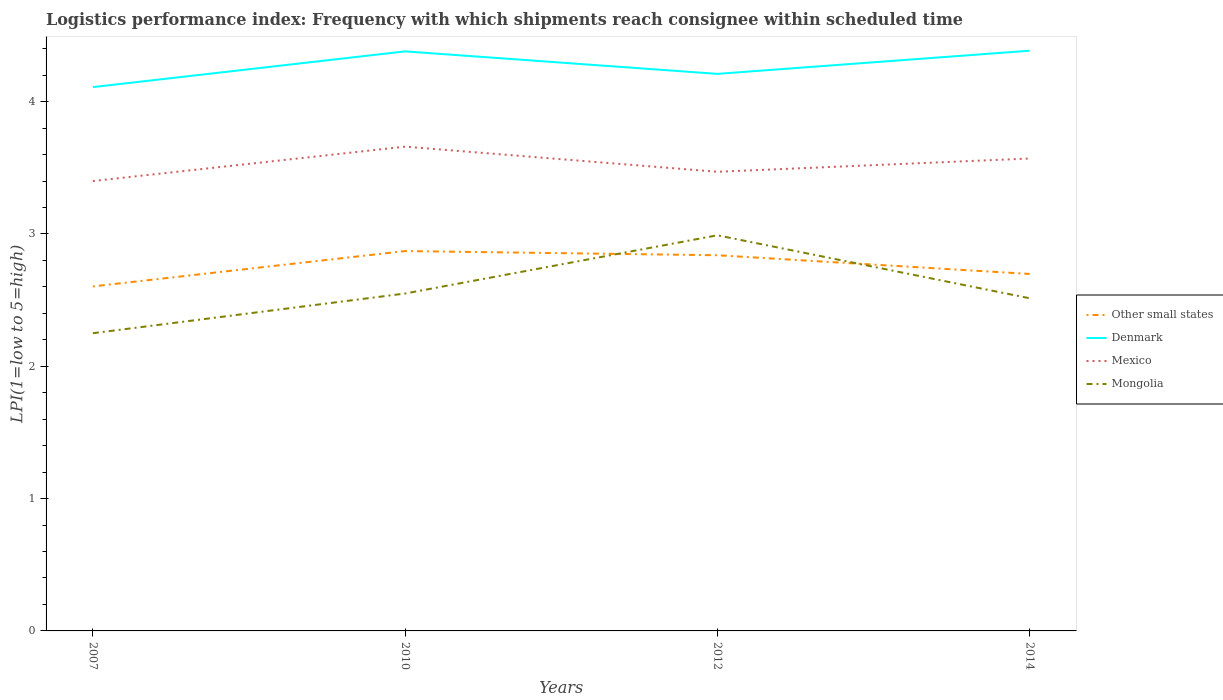How many different coloured lines are there?
Keep it short and to the point. 4. Across all years, what is the maximum logistics performance index in Other small states?
Keep it short and to the point. 2.6. In which year was the logistics performance index in Denmark maximum?
Provide a succinct answer. 2007. What is the total logistics performance index in Denmark in the graph?
Your answer should be very brief. 0.17. What is the difference between the highest and the second highest logistics performance index in Mongolia?
Your answer should be compact. 0.74. Is the logistics performance index in Mongolia strictly greater than the logistics performance index in Other small states over the years?
Your answer should be compact. No. How many lines are there?
Your response must be concise. 4. Are the values on the major ticks of Y-axis written in scientific E-notation?
Your response must be concise. No. Does the graph contain any zero values?
Give a very brief answer. No. Does the graph contain grids?
Offer a terse response. No. Where does the legend appear in the graph?
Provide a succinct answer. Center right. How are the legend labels stacked?
Ensure brevity in your answer.  Vertical. What is the title of the graph?
Your response must be concise. Logistics performance index: Frequency with which shipments reach consignee within scheduled time. What is the label or title of the X-axis?
Give a very brief answer. Years. What is the label or title of the Y-axis?
Provide a succinct answer. LPI(1=low to 5=high). What is the LPI(1=low to 5=high) of Other small states in 2007?
Ensure brevity in your answer.  2.6. What is the LPI(1=low to 5=high) of Denmark in 2007?
Your response must be concise. 4.11. What is the LPI(1=low to 5=high) in Mongolia in 2007?
Your answer should be very brief. 2.25. What is the LPI(1=low to 5=high) in Other small states in 2010?
Your answer should be compact. 2.87. What is the LPI(1=low to 5=high) in Denmark in 2010?
Offer a terse response. 4.38. What is the LPI(1=low to 5=high) in Mexico in 2010?
Your response must be concise. 3.66. What is the LPI(1=low to 5=high) of Mongolia in 2010?
Ensure brevity in your answer.  2.55. What is the LPI(1=low to 5=high) of Other small states in 2012?
Your response must be concise. 2.84. What is the LPI(1=low to 5=high) of Denmark in 2012?
Provide a succinct answer. 4.21. What is the LPI(1=low to 5=high) in Mexico in 2012?
Offer a very short reply. 3.47. What is the LPI(1=low to 5=high) in Mongolia in 2012?
Offer a very short reply. 2.99. What is the LPI(1=low to 5=high) of Other small states in 2014?
Keep it short and to the point. 2.7. What is the LPI(1=low to 5=high) of Denmark in 2014?
Your answer should be compact. 4.39. What is the LPI(1=low to 5=high) in Mexico in 2014?
Give a very brief answer. 3.57. What is the LPI(1=low to 5=high) in Mongolia in 2014?
Offer a very short reply. 2.51. Across all years, what is the maximum LPI(1=low to 5=high) of Other small states?
Give a very brief answer. 2.87. Across all years, what is the maximum LPI(1=low to 5=high) in Denmark?
Offer a terse response. 4.39. Across all years, what is the maximum LPI(1=low to 5=high) in Mexico?
Ensure brevity in your answer.  3.66. Across all years, what is the maximum LPI(1=low to 5=high) of Mongolia?
Provide a short and direct response. 2.99. Across all years, what is the minimum LPI(1=low to 5=high) in Other small states?
Your response must be concise. 2.6. Across all years, what is the minimum LPI(1=low to 5=high) in Denmark?
Give a very brief answer. 4.11. Across all years, what is the minimum LPI(1=low to 5=high) of Mexico?
Provide a succinct answer. 3.4. Across all years, what is the minimum LPI(1=low to 5=high) in Mongolia?
Provide a short and direct response. 2.25. What is the total LPI(1=low to 5=high) of Other small states in the graph?
Keep it short and to the point. 11.01. What is the total LPI(1=low to 5=high) of Denmark in the graph?
Your answer should be very brief. 17.09. What is the total LPI(1=low to 5=high) of Mexico in the graph?
Give a very brief answer. 14.1. What is the total LPI(1=low to 5=high) in Mongolia in the graph?
Your response must be concise. 10.3. What is the difference between the LPI(1=low to 5=high) in Other small states in 2007 and that in 2010?
Your answer should be very brief. -0.27. What is the difference between the LPI(1=low to 5=high) of Denmark in 2007 and that in 2010?
Your answer should be very brief. -0.27. What is the difference between the LPI(1=low to 5=high) in Mexico in 2007 and that in 2010?
Your answer should be very brief. -0.26. What is the difference between the LPI(1=low to 5=high) of Mongolia in 2007 and that in 2010?
Provide a succinct answer. -0.3. What is the difference between the LPI(1=low to 5=high) in Other small states in 2007 and that in 2012?
Your answer should be compact. -0.24. What is the difference between the LPI(1=low to 5=high) in Mexico in 2007 and that in 2012?
Your answer should be compact. -0.07. What is the difference between the LPI(1=low to 5=high) in Mongolia in 2007 and that in 2012?
Give a very brief answer. -0.74. What is the difference between the LPI(1=low to 5=high) of Other small states in 2007 and that in 2014?
Offer a terse response. -0.09. What is the difference between the LPI(1=low to 5=high) of Denmark in 2007 and that in 2014?
Your answer should be compact. -0.28. What is the difference between the LPI(1=low to 5=high) of Mexico in 2007 and that in 2014?
Your answer should be very brief. -0.17. What is the difference between the LPI(1=low to 5=high) in Mongolia in 2007 and that in 2014?
Make the answer very short. -0.26. What is the difference between the LPI(1=low to 5=high) of Other small states in 2010 and that in 2012?
Your answer should be very brief. 0.03. What is the difference between the LPI(1=low to 5=high) of Denmark in 2010 and that in 2012?
Your answer should be very brief. 0.17. What is the difference between the LPI(1=low to 5=high) in Mexico in 2010 and that in 2012?
Provide a succinct answer. 0.19. What is the difference between the LPI(1=low to 5=high) of Mongolia in 2010 and that in 2012?
Offer a terse response. -0.44. What is the difference between the LPI(1=low to 5=high) in Other small states in 2010 and that in 2014?
Ensure brevity in your answer.  0.17. What is the difference between the LPI(1=low to 5=high) of Denmark in 2010 and that in 2014?
Make the answer very short. -0.01. What is the difference between the LPI(1=low to 5=high) of Mexico in 2010 and that in 2014?
Ensure brevity in your answer.  0.09. What is the difference between the LPI(1=low to 5=high) of Mongolia in 2010 and that in 2014?
Your answer should be compact. 0.04. What is the difference between the LPI(1=low to 5=high) in Other small states in 2012 and that in 2014?
Offer a very short reply. 0.14. What is the difference between the LPI(1=low to 5=high) of Denmark in 2012 and that in 2014?
Make the answer very short. -0.18. What is the difference between the LPI(1=low to 5=high) in Mexico in 2012 and that in 2014?
Make the answer very short. -0.1. What is the difference between the LPI(1=low to 5=high) in Mongolia in 2012 and that in 2014?
Your answer should be very brief. 0.48. What is the difference between the LPI(1=low to 5=high) in Other small states in 2007 and the LPI(1=low to 5=high) in Denmark in 2010?
Keep it short and to the point. -1.78. What is the difference between the LPI(1=low to 5=high) of Other small states in 2007 and the LPI(1=low to 5=high) of Mexico in 2010?
Offer a very short reply. -1.06. What is the difference between the LPI(1=low to 5=high) of Other small states in 2007 and the LPI(1=low to 5=high) of Mongolia in 2010?
Give a very brief answer. 0.05. What is the difference between the LPI(1=low to 5=high) in Denmark in 2007 and the LPI(1=low to 5=high) in Mexico in 2010?
Provide a short and direct response. 0.45. What is the difference between the LPI(1=low to 5=high) in Denmark in 2007 and the LPI(1=low to 5=high) in Mongolia in 2010?
Give a very brief answer. 1.56. What is the difference between the LPI(1=low to 5=high) in Mexico in 2007 and the LPI(1=low to 5=high) in Mongolia in 2010?
Provide a short and direct response. 0.85. What is the difference between the LPI(1=low to 5=high) in Other small states in 2007 and the LPI(1=low to 5=high) in Denmark in 2012?
Provide a succinct answer. -1.61. What is the difference between the LPI(1=low to 5=high) of Other small states in 2007 and the LPI(1=low to 5=high) of Mexico in 2012?
Your response must be concise. -0.87. What is the difference between the LPI(1=low to 5=high) of Other small states in 2007 and the LPI(1=low to 5=high) of Mongolia in 2012?
Provide a succinct answer. -0.39. What is the difference between the LPI(1=low to 5=high) in Denmark in 2007 and the LPI(1=low to 5=high) in Mexico in 2012?
Your response must be concise. 0.64. What is the difference between the LPI(1=low to 5=high) of Denmark in 2007 and the LPI(1=low to 5=high) of Mongolia in 2012?
Make the answer very short. 1.12. What is the difference between the LPI(1=low to 5=high) of Mexico in 2007 and the LPI(1=low to 5=high) of Mongolia in 2012?
Keep it short and to the point. 0.41. What is the difference between the LPI(1=low to 5=high) of Other small states in 2007 and the LPI(1=low to 5=high) of Denmark in 2014?
Keep it short and to the point. -1.78. What is the difference between the LPI(1=low to 5=high) in Other small states in 2007 and the LPI(1=low to 5=high) in Mexico in 2014?
Keep it short and to the point. -0.97. What is the difference between the LPI(1=low to 5=high) in Other small states in 2007 and the LPI(1=low to 5=high) in Mongolia in 2014?
Provide a succinct answer. 0.09. What is the difference between the LPI(1=low to 5=high) in Denmark in 2007 and the LPI(1=low to 5=high) in Mexico in 2014?
Your response must be concise. 0.54. What is the difference between the LPI(1=low to 5=high) in Denmark in 2007 and the LPI(1=low to 5=high) in Mongolia in 2014?
Offer a very short reply. 1.6. What is the difference between the LPI(1=low to 5=high) in Mexico in 2007 and the LPI(1=low to 5=high) in Mongolia in 2014?
Ensure brevity in your answer.  0.89. What is the difference between the LPI(1=low to 5=high) in Other small states in 2010 and the LPI(1=low to 5=high) in Denmark in 2012?
Ensure brevity in your answer.  -1.34. What is the difference between the LPI(1=low to 5=high) in Other small states in 2010 and the LPI(1=low to 5=high) in Mexico in 2012?
Your response must be concise. -0.6. What is the difference between the LPI(1=low to 5=high) in Other small states in 2010 and the LPI(1=low to 5=high) in Mongolia in 2012?
Give a very brief answer. -0.12. What is the difference between the LPI(1=low to 5=high) of Denmark in 2010 and the LPI(1=low to 5=high) of Mexico in 2012?
Offer a very short reply. 0.91. What is the difference between the LPI(1=low to 5=high) in Denmark in 2010 and the LPI(1=low to 5=high) in Mongolia in 2012?
Offer a very short reply. 1.39. What is the difference between the LPI(1=low to 5=high) of Mexico in 2010 and the LPI(1=low to 5=high) of Mongolia in 2012?
Provide a succinct answer. 0.67. What is the difference between the LPI(1=low to 5=high) in Other small states in 2010 and the LPI(1=low to 5=high) in Denmark in 2014?
Your answer should be compact. -1.51. What is the difference between the LPI(1=low to 5=high) of Other small states in 2010 and the LPI(1=low to 5=high) of Mexico in 2014?
Your answer should be compact. -0.7. What is the difference between the LPI(1=low to 5=high) of Other small states in 2010 and the LPI(1=low to 5=high) of Mongolia in 2014?
Give a very brief answer. 0.36. What is the difference between the LPI(1=low to 5=high) of Denmark in 2010 and the LPI(1=low to 5=high) of Mexico in 2014?
Give a very brief answer. 0.81. What is the difference between the LPI(1=low to 5=high) in Denmark in 2010 and the LPI(1=low to 5=high) in Mongolia in 2014?
Provide a succinct answer. 1.87. What is the difference between the LPI(1=low to 5=high) in Mexico in 2010 and the LPI(1=low to 5=high) in Mongolia in 2014?
Give a very brief answer. 1.15. What is the difference between the LPI(1=low to 5=high) of Other small states in 2012 and the LPI(1=low to 5=high) of Denmark in 2014?
Your answer should be very brief. -1.55. What is the difference between the LPI(1=low to 5=high) in Other small states in 2012 and the LPI(1=low to 5=high) in Mexico in 2014?
Your response must be concise. -0.73. What is the difference between the LPI(1=low to 5=high) in Other small states in 2012 and the LPI(1=low to 5=high) in Mongolia in 2014?
Ensure brevity in your answer.  0.33. What is the difference between the LPI(1=low to 5=high) in Denmark in 2012 and the LPI(1=low to 5=high) in Mexico in 2014?
Provide a short and direct response. 0.64. What is the difference between the LPI(1=low to 5=high) in Denmark in 2012 and the LPI(1=low to 5=high) in Mongolia in 2014?
Offer a very short reply. 1.7. What is the difference between the LPI(1=low to 5=high) in Mexico in 2012 and the LPI(1=low to 5=high) in Mongolia in 2014?
Make the answer very short. 0.96. What is the average LPI(1=low to 5=high) of Other small states per year?
Provide a succinct answer. 2.75. What is the average LPI(1=low to 5=high) of Denmark per year?
Your answer should be compact. 4.27. What is the average LPI(1=low to 5=high) of Mexico per year?
Provide a succinct answer. 3.53. What is the average LPI(1=low to 5=high) of Mongolia per year?
Your answer should be very brief. 2.58. In the year 2007, what is the difference between the LPI(1=low to 5=high) in Other small states and LPI(1=low to 5=high) in Denmark?
Provide a succinct answer. -1.51. In the year 2007, what is the difference between the LPI(1=low to 5=high) in Other small states and LPI(1=low to 5=high) in Mexico?
Make the answer very short. -0.8. In the year 2007, what is the difference between the LPI(1=low to 5=high) in Other small states and LPI(1=low to 5=high) in Mongolia?
Your answer should be compact. 0.35. In the year 2007, what is the difference between the LPI(1=low to 5=high) in Denmark and LPI(1=low to 5=high) in Mexico?
Ensure brevity in your answer.  0.71. In the year 2007, what is the difference between the LPI(1=low to 5=high) of Denmark and LPI(1=low to 5=high) of Mongolia?
Your answer should be very brief. 1.86. In the year 2007, what is the difference between the LPI(1=low to 5=high) in Mexico and LPI(1=low to 5=high) in Mongolia?
Give a very brief answer. 1.15. In the year 2010, what is the difference between the LPI(1=low to 5=high) in Other small states and LPI(1=low to 5=high) in Denmark?
Offer a very short reply. -1.51. In the year 2010, what is the difference between the LPI(1=low to 5=high) in Other small states and LPI(1=low to 5=high) in Mexico?
Offer a very short reply. -0.79. In the year 2010, what is the difference between the LPI(1=low to 5=high) of Other small states and LPI(1=low to 5=high) of Mongolia?
Provide a succinct answer. 0.32. In the year 2010, what is the difference between the LPI(1=low to 5=high) in Denmark and LPI(1=low to 5=high) in Mexico?
Make the answer very short. 0.72. In the year 2010, what is the difference between the LPI(1=low to 5=high) of Denmark and LPI(1=low to 5=high) of Mongolia?
Your response must be concise. 1.83. In the year 2010, what is the difference between the LPI(1=low to 5=high) of Mexico and LPI(1=low to 5=high) of Mongolia?
Your response must be concise. 1.11. In the year 2012, what is the difference between the LPI(1=low to 5=high) of Other small states and LPI(1=low to 5=high) of Denmark?
Your answer should be compact. -1.37. In the year 2012, what is the difference between the LPI(1=low to 5=high) of Other small states and LPI(1=low to 5=high) of Mexico?
Offer a terse response. -0.63. In the year 2012, what is the difference between the LPI(1=low to 5=high) in Other small states and LPI(1=low to 5=high) in Mongolia?
Provide a short and direct response. -0.15. In the year 2012, what is the difference between the LPI(1=low to 5=high) in Denmark and LPI(1=low to 5=high) in Mexico?
Offer a terse response. 0.74. In the year 2012, what is the difference between the LPI(1=low to 5=high) of Denmark and LPI(1=low to 5=high) of Mongolia?
Provide a short and direct response. 1.22. In the year 2012, what is the difference between the LPI(1=low to 5=high) of Mexico and LPI(1=low to 5=high) of Mongolia?
Give a very brief answer. 0.48. In the year 2014, what is the difference between the LPI(1=low to 5=high) in Other small states and LPI(1=low to 5=high) in Denmark?
Provide a succinct answer. -1.69. In the year 2014, what is the difference between the LPI(1=low to 5=high) of Other small states and LPI(1=low to 5=high) of Mexico?
Give a very brief answer. -0.87. In the year 2014, what is the difference between the LPI(1=low to 5=high) in Other small states and LPI(1=low to 5=high) in Mongolia?
Offer a terse response. 0.18. In the year 2014, what is the difference between the LPI(1=low to 5=high) in Denmark and LPI(1=low to 5=high) in Mexico?
Your answer should be very brief. 0.81. In the year 2014, what is the difference between the LPI(1=low to 5=high) in Denmark and LPI(1=low to 5=high) in Mongolia?
Ensure brevity in your answer.  1.87. In the year 2014, what is the difference between the LPI(1=low to 5=high) of Mexico and LPI(1=low to 5=high) of Mongolia?
Make the answer very short. 1.06. What is the ratio of the LPI(1=low to 5=high) in Other small states in 2007 to that in 2010?
Offer a very short reply. 0.91. What is the ratio of the LPI(1=low to 5=high) of Denmark in 2007 to that in 2010?
Your answer should be very brief. 0.94. What is the ratio of the LPI(1=low to 5=high) of Mexico in 2007 to that in 2010?
Offer a terse response. 0.93. What is the ratio of the LPI(1=low to 5=high) in Mongolia in 2007 to that in 2010?
Ensure brevity in your answer.  0.88. What is the ratio of the LPI(1=low to 5=high) in Other small states in 2007 to that in 2012?
Keep it short and to the point. 0.92. What is the ratio of the LPI(1=low to 5=high) of Denmark in 2007 to that in 2012?
Offer a terse response. 0.98. What is the ratio of the LPI(1=low to 5=high) of Mexico in 2007 to that in 2012?
Offer a terse response. 0.98. What is the ratio of the LPI(1=low to 5=high) of Mongolia in 2007 to that in 2012?
Ensure brevity in your answer.  0.75. What is the ratio of the LPI(1=low to 5=high) in Other small states in 2007 to that in 2014?
Your response must be concise. 0.97. What is the ratio of the LPI(1=low to 5=high) in Denmark in 2007 to that in 2014?
Offer a terse response. 0.94. What is the ratio of the LPI(1=low to 5=high) of Mexico in 2007 to that in 2014?
Give a very brief answer. 0.95. What is the ratio of the LPI(1=low to 5=high) in Mongolia in 2007 to that in 2014?
Your response must be concise. 0.89. What is the ratio of the LPI(1=low to 5=high) of Other small states in 2010 to that in 2012?
Provide a short and direct response. 1.01. What is the ratio of the LPI(1=low to 5=high) in Denmark in 2010 to that in 2012?
Provide a short and direct response. 1.04. What is the ratio of the LPI(1=low to 5=high) of Mexico in 2010 to that in 2012?
Your response must be concise. 1.05. What is the ratio of the LPI(1=low to 5=high) in Mongolia in 2010 to that in 2012?
Provide a short and direct response. 0.85. What is the ratio of the LPI(1=low to 5=high) in Other small states in 2010 to that in 2014?
Your answer should be compact. 1.06. What is the ratio of the LPI(1=low to 5=high) of Denmark in 2010 to that in 2014?
Your response must be concise. 1. What is the ratio of the LPI(1=low to 5=high) of Mexico in 2010 to that in 2014?
Provide a short and direct response. 1.03. What is the ratio of the LPI(1=low to 5=high) in Mongolia in 2010 to that in 2014?
Your response must be concise. 1.01. What is the ratio of the LPI(1=low to 5=high) of Other small states in 2012 to that in 2014?
Offer a very short reply. 1.05. What is the ratio of the LPI(1=low to 5=high) of Denmark in 2012 to that in 2014?
Provide a succinct answer. 0.96. What is the ratio of the LPI(1=low to 5=high) in Mexico in 2012 to that in 2014?
Your answer should be compact. 0.97. What is the ratio of the LPI(1=low to 5=high) in Mongolia in 2012 to that in 2014?
Ensure brevity in your answer.  1.19. What is the difference between the highest and the second highest LPI(1=low to 5=high) in Other small states?
Offer a very short reply. 0.03. What is the difference between the highest and the second highest LPI(1=low to 5=high) in Denmark?
Your response must be concise. 0.01. What is the difference between the highest and the second highest LPI(1=low to 5=high) in Mexico?
Your answer should be compact. 0.09. What is the difference between the highest and the second highest LPI(1=low to 5=high) of Mongolia?
Your response must be concise. 0.44. What is the difference between the highest and the lowest LPI(1=low to 5=high) in Other small states?
Your answer should be very brief. 0.27. What is the difference between the highest and the lowest LPI(1=low to 5=high) of Denmark?
Provide a short and direct response. 0.28. What is the difference between the highest and the lowest LPI(1=low to 5=high) in Mexico?
Give a very brief answer. 0.26. What is the difference between the highest and the lowest LPI(1=low to 5=high) of Mongolia?
Offer a terse response. 0.74. 